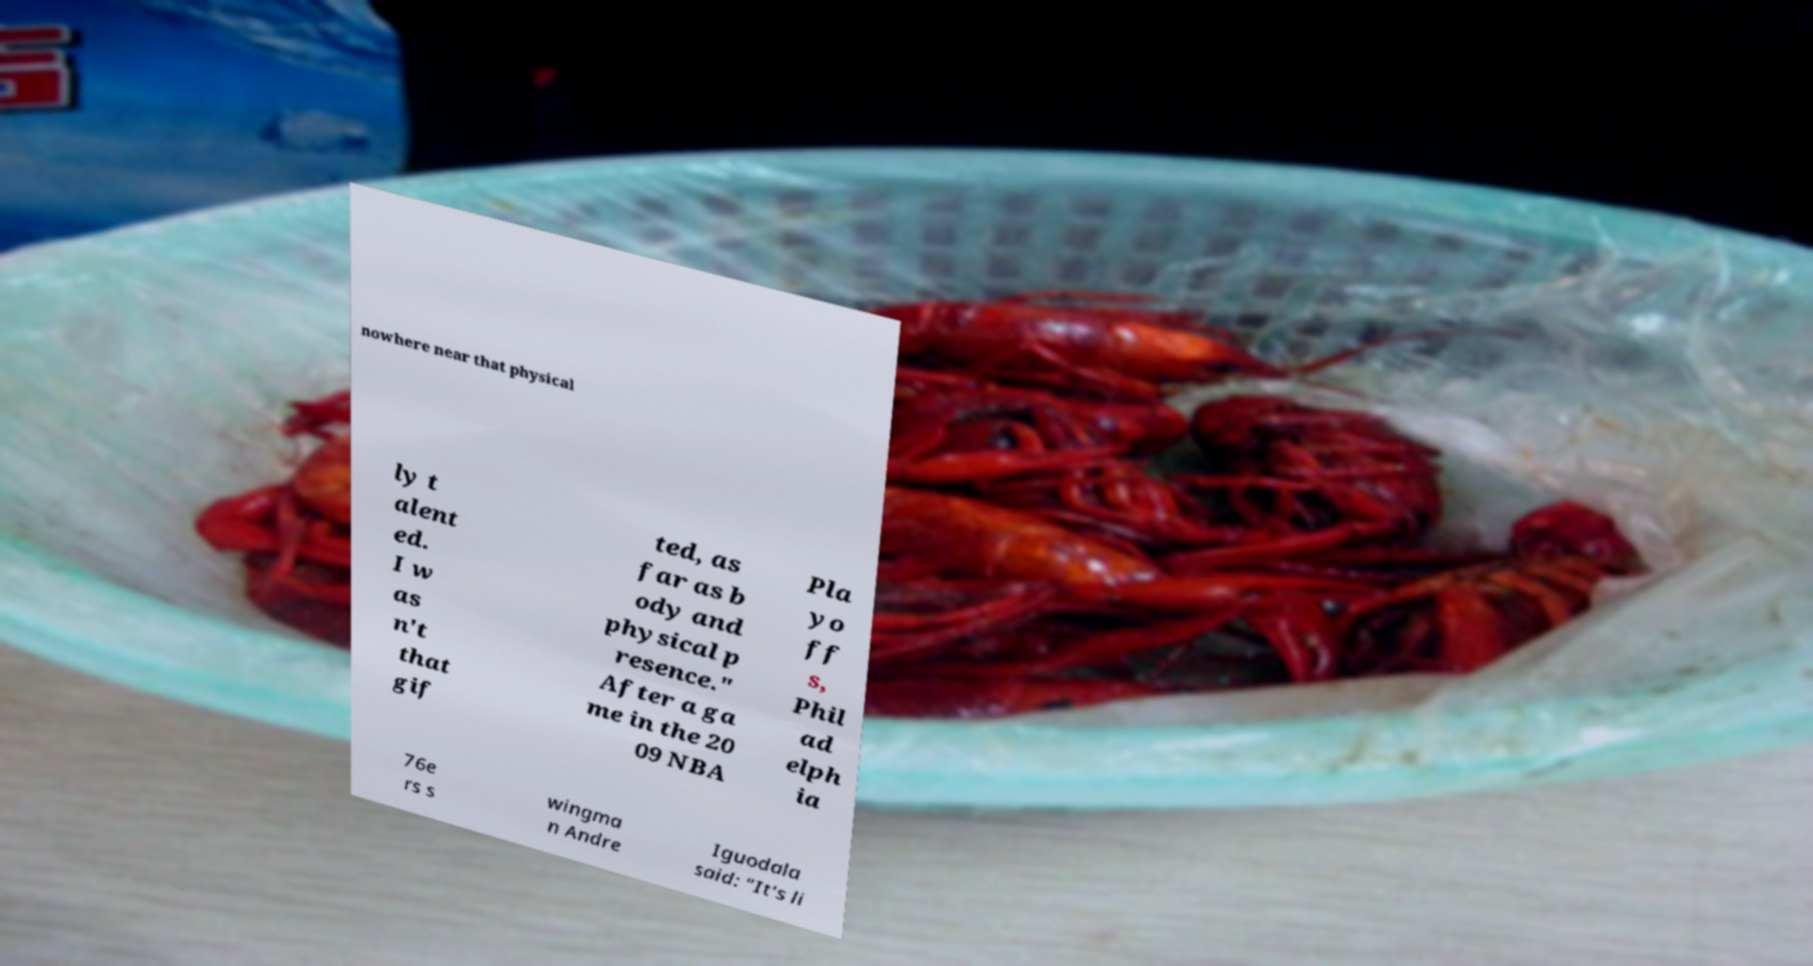There's text embedded in this image that I need extracted. Can you transcribe it verbatim? nowhere near that physical ly t alent ed. I w as n't that gif ted, as far as b ody and physical p resence." After a ga me in the 20 09 NBA Pla yo ff s, Phil ad elph ia 76e rs s wingma n Andre Iguodala said: "It's li 